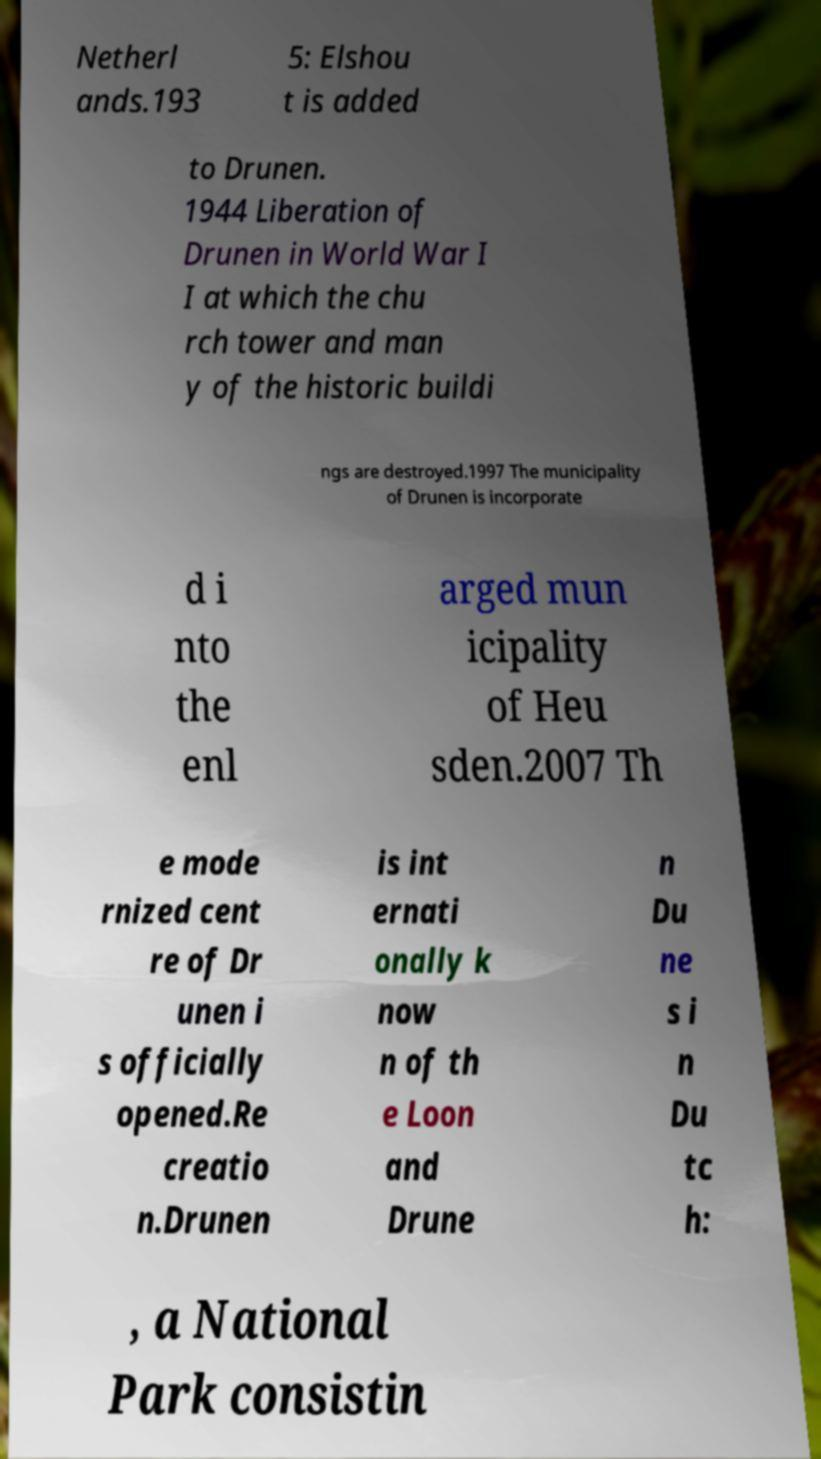I need the written content from this picture converted into text. Can you do that? Netherl ands.193 5: Elshou t is added to Drunen. 1944 Liberation of Drunen in World War I I at which the chu rch tower and man y of the historic buildi ngs are destroyed.1997 The municipality of Drunen is incorporate d i nto the enl arged mun icipality of Heu sden.2007 Th e mode rnized cent re of Dr unen i s officially opened.Re creatio n.Drunen is int ernati onally k now n of th e Loon and Drune n Du ne s i n Du tc h: , a National Park consistin 